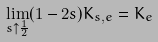Convert formula to latex. <formula><loc_0><loc_0><loc_500><loc_500>\lim _ { s \uparrow \frac { 1 } { 2 } } ( 1 - 2 s ) K _ { s , e } = K _ { e }</formula> 